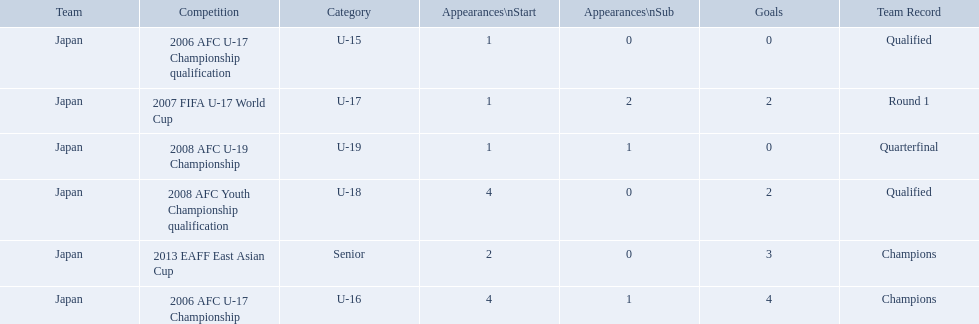Which competitions had champions team records? 2006 AFC U-17 Championship, 2013 EAFF East Asian Cup. Of these competitions, which one was in the senior category? 2013 EAFF East Asian Cup. 